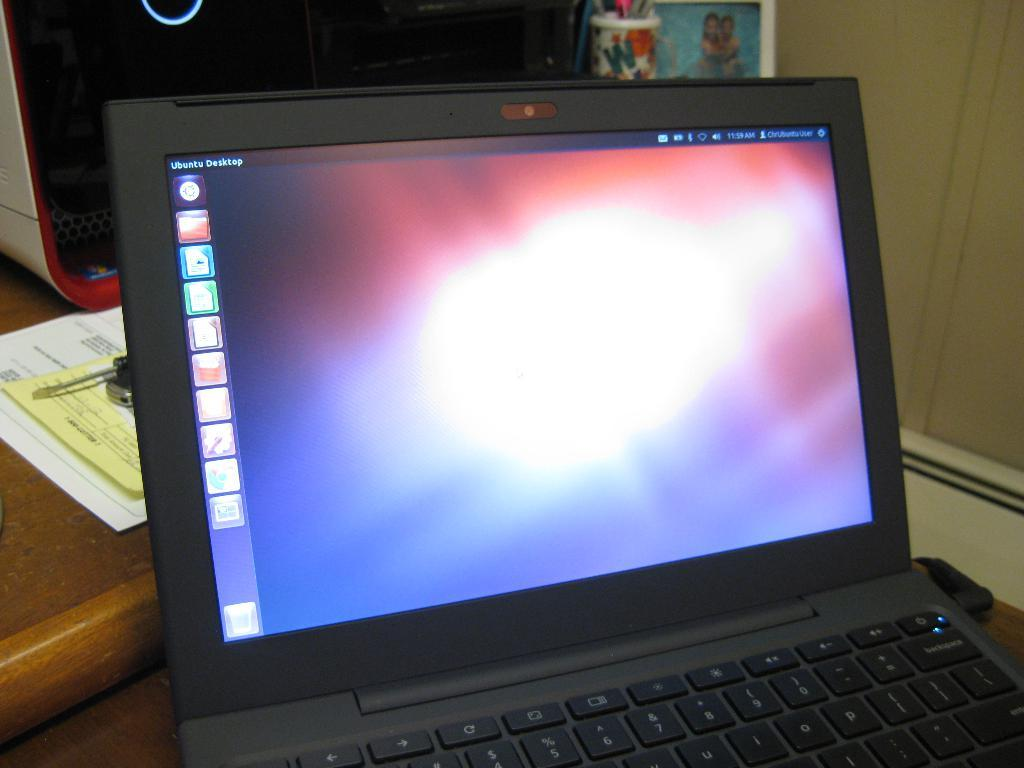<image>
Write a terse but informative summary of the picture. A computer on a table on with turned on with UBUntu Desktop in the left corner 